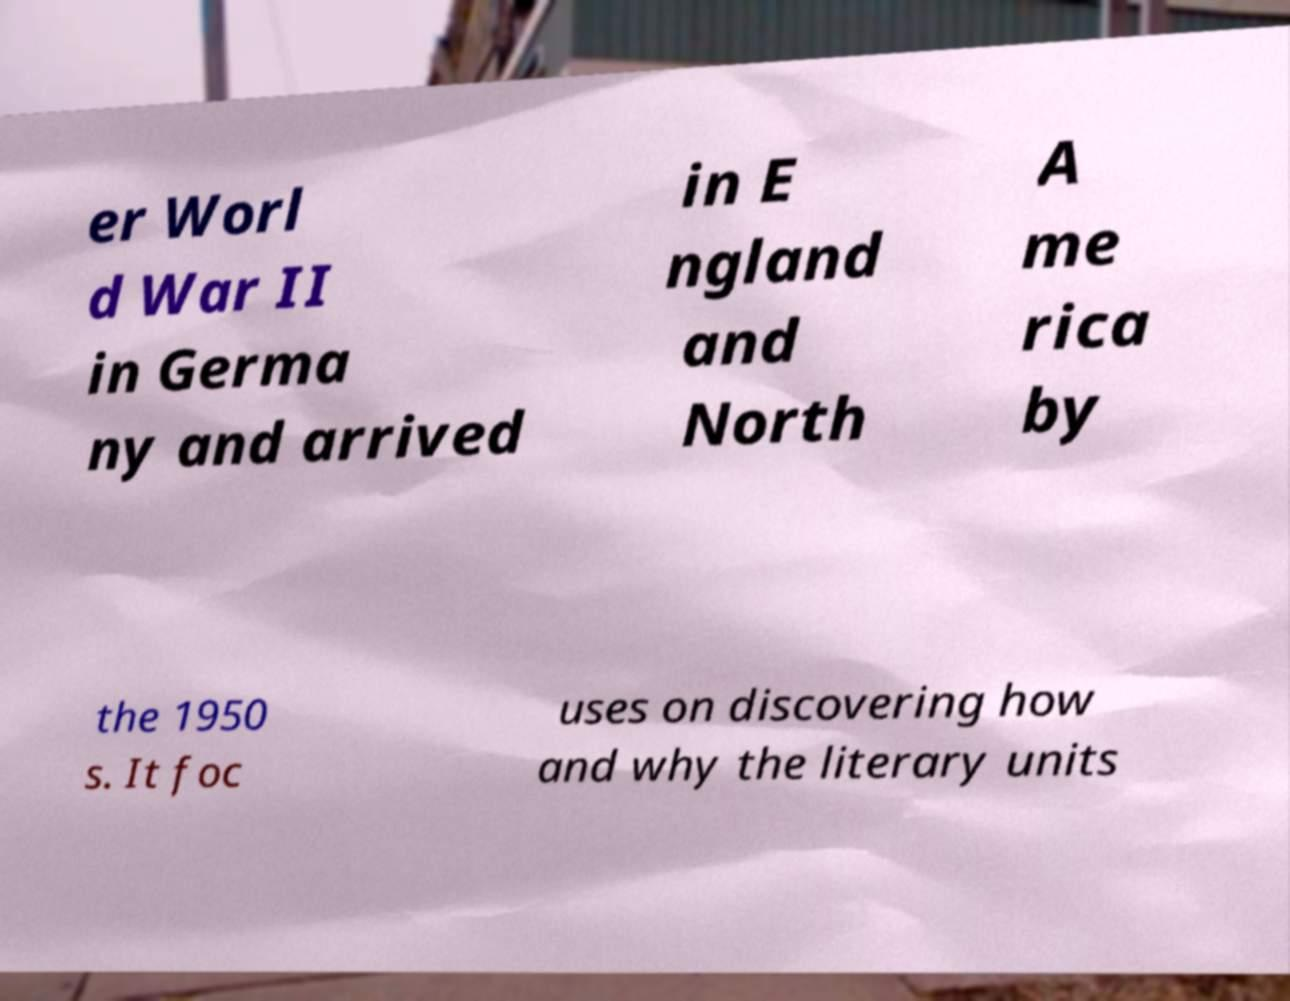Could you assist in decoding the text presented in this image and type it out clearly? er Worl d War II in Germa ny and arrived in E ngland and North A me rica by the 1950 s. It foc uses on discovering how and why the literary units 